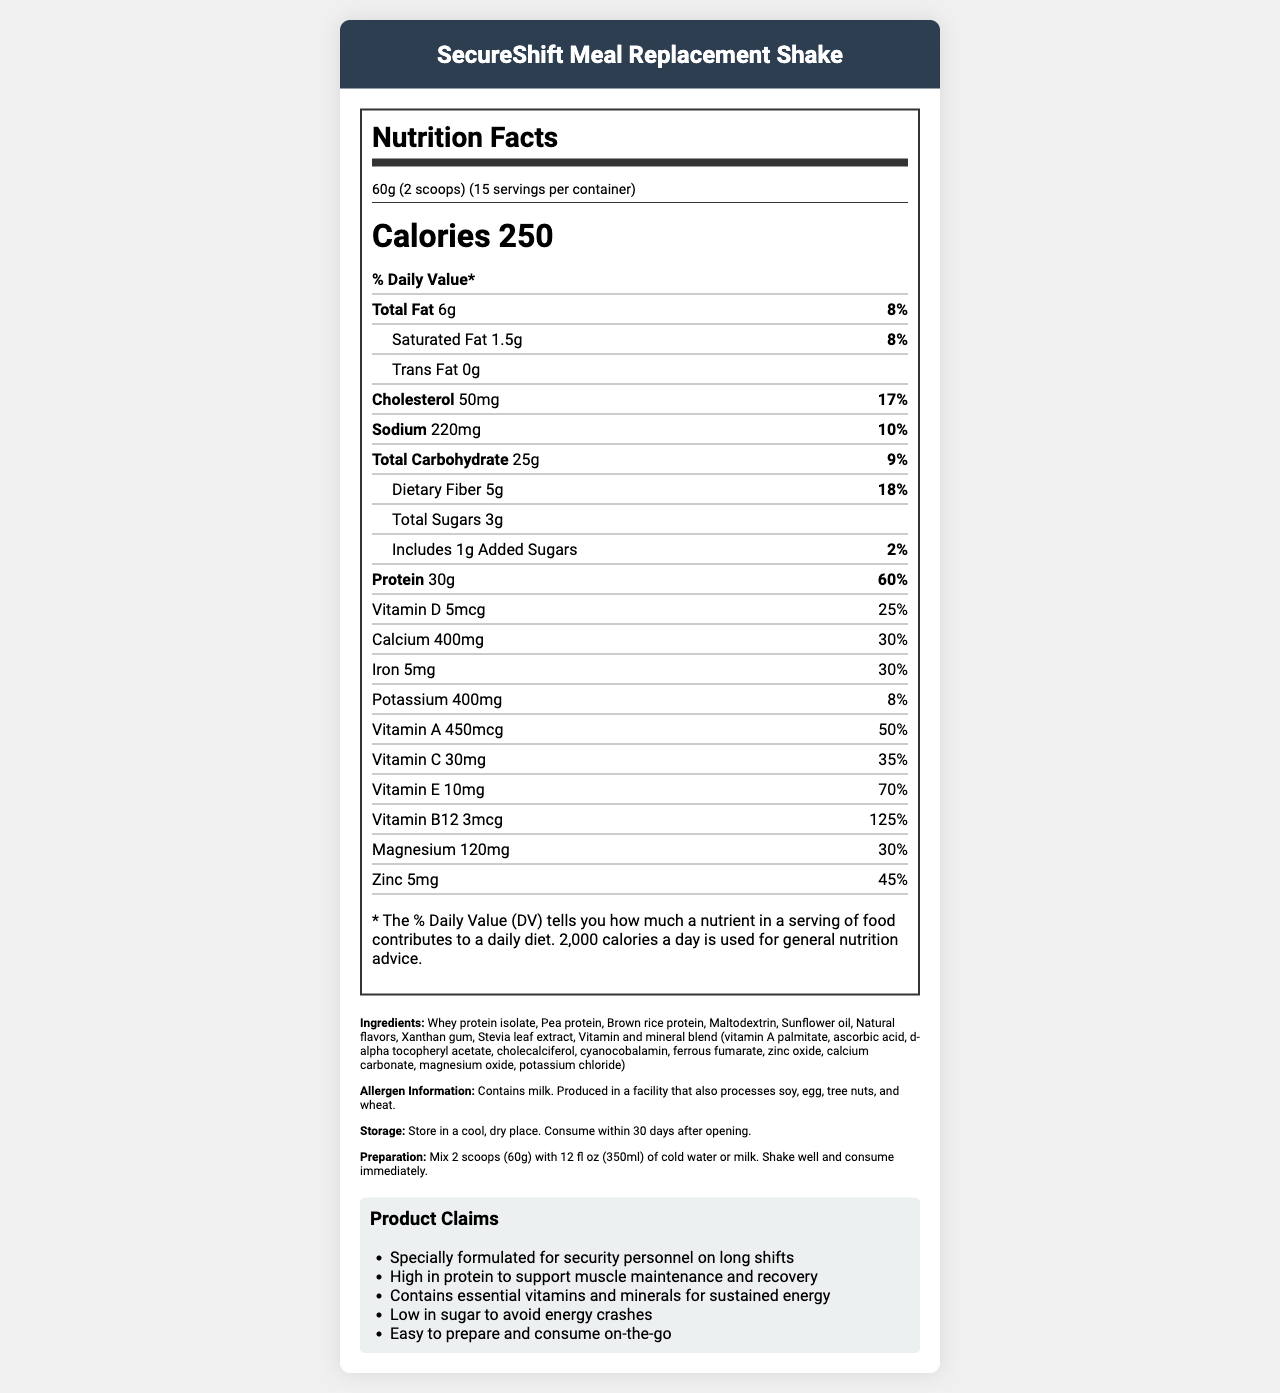what is the serving size? The serving size is explicitly mentioned as "60g (2 scoops)" in the document.
Answer: 60g (2 scoops) how many servings are in each container? The document states that there are 15 servings per container.
Answer: 15 how many calories are in one serving of the SecureShift Meal Replacement Shake? The Nutrition Facts label lists 250 calories per serving.
Answer: 250 calories what is the amount of protein in one serving? According to the Nutrition Facts label, one serving contains 30 grams of protein.
Answer: 30g how much dietary fiber is in one serving? The document specifies that there are 5 grams of dietary fiber per serving.
Answer: 5g what percentage of the daily value for vitamin D does one serving provide? The Nutrition Facts label shows that one serving provides 25% of the daily value for vitamin D.
Answer: 25% how much sodium is in one serving in milligrams and percentage daily value? One serving contains 220 milligrams of sodium, which is 10% of the daily value.
Answer: 220mg, 10% which of the following vitamins has the highest daily value percentage?
I. Vitamin E
II. Vitamin C
III. Vitamin B12
IV. Vitamin A Vitamin B12 has the highest daily value percentage at 125%, followed by Vitamin E at 70%, Vitamin A at 50%, and Vitamin C at 35%.
Answer: III. Vitamin B12 which ingredient in the SecureShift Meal Replacement Shake is found in the vitamin and mineral blend?
A. Maltodextrin
B. Potassium chloride
C. Sunflower oil
D. Stevia leaf extract The vitamin and mineral blend in the ingredients list includes "potassium chloride."
Answer: B. Potassium chloride is the SecureShift Meal Replacement Shake gluten-free? The document does not provide information on whether the product is gluten-free.
Answer: Cannot be determined does the SecureShift Meal Replacement Shake contain any tree nuts? However, it is produced in a facility that also processes tree nuts.
Answer: No what are the marketing claims made about the SecureShift Meal Replacement Shake? The document lists these marketing claims explicitly in the product claims section.
Answer: Specially formulated for security personnel on long shifts, High in protein to support muscle maintenance and recovery, Contains essential vitamins and minerals for sustained energy, Low in sugar to avoid energy crashes, Easy to prepare and consume on-the-go describe the main nutritional features of the SecureShift Meal Replacement Shake This answer summarizes the primary nutritional aspects based on the data provided in the Nutrition Facts label.
Answer: The SecureShift Meal Replacement Shake is designed for security personnel on long shifts. It provides 250 calories per serving, with high protein content (30g per serving) and essential vitamins and minerals like Vitamin B12, Vitamin E, Calcium, and Iron. It is low in sugar with 3g total sugars, including 1g added sugars. It also includes dietary fiber (5g) and moderate amounts of fats and sodium. what is the preparation instruction for the SecureShift Meal Replacement Shake? The document cites the preparation instructions in the ingredients and additional information section.
Answer: Mix 2 scoops (60g) with 12 fl oz (350ml) of cold water or milk. Shake well and consume immediately. how many grams of total carbohydrates are there in one serving, and what is the percentage daily value? One serving contains 25 grams of total carbohydrates, which is 9% of the daily value.
Answer: 25g, 9% what allergens are present in the SecureShift Meal Replacement Shake? The allergen information is explicitly mentioned in the document.
Answer: Contains milk. Produced in a facility that also processes soy, egg, tree nuts, and wheat. 